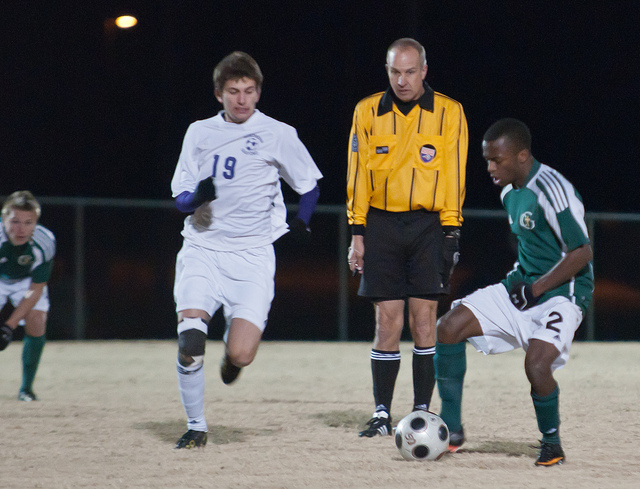Read and extract the text from this image. 19 I 2 